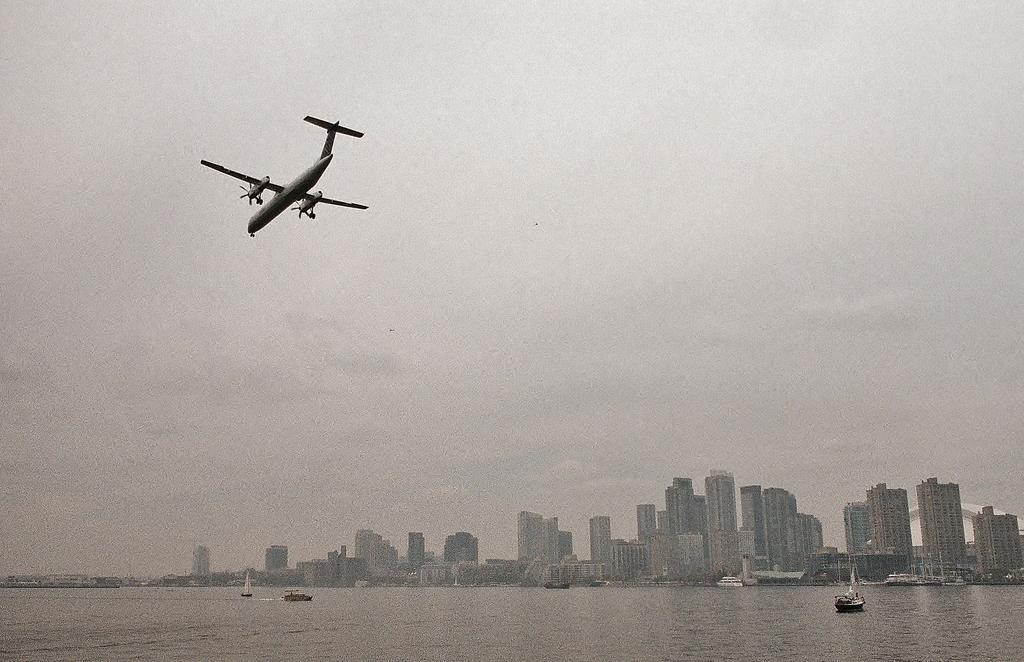How would you summarize this image in a sentence or two? This picture is clicked outside. In the foreground we can see the boats and some other objects in the water body. In the background we can see the sky, buildings and some other objects. At the top we can see an airplane flying in the sky and we can see many other objects in the background. 